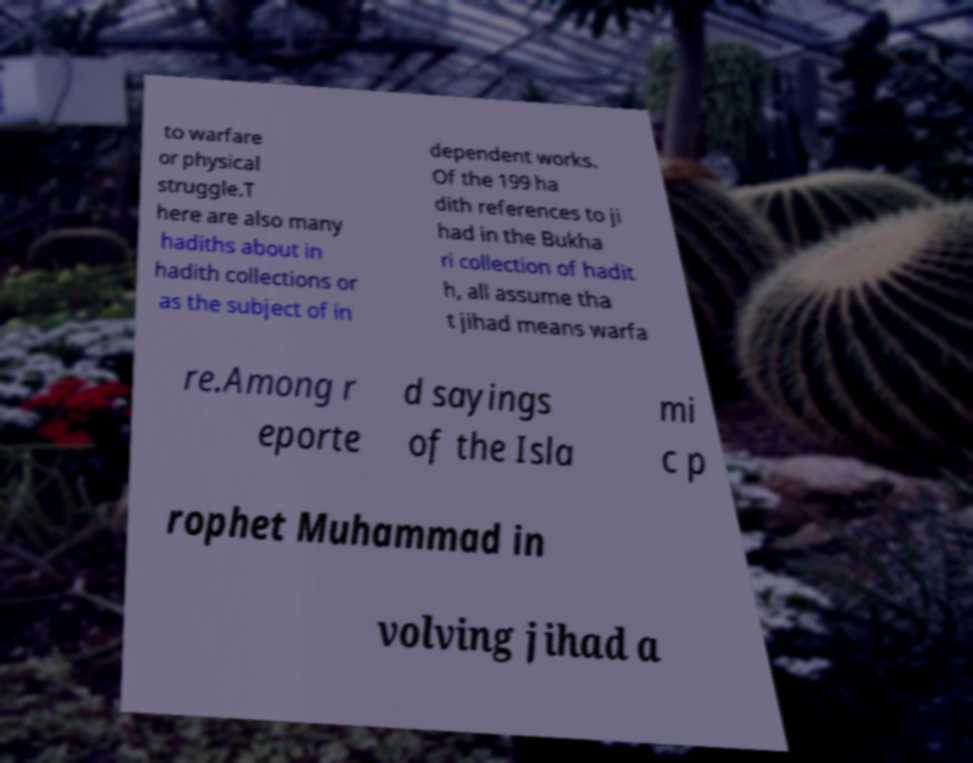I need the written content from this picture converted into text. Can you do that? to warfare or physical struggle.T here are also many hadiths about in hadith collections or as the subject of in dependent works. Of the 199 ha dith references to ji had in the Bukha ri collection of hadit h, all assume tha t jihad means warfa re.Among r eporte d sayings of the Isla mi c p rophet Muhammad in volving jihad a 